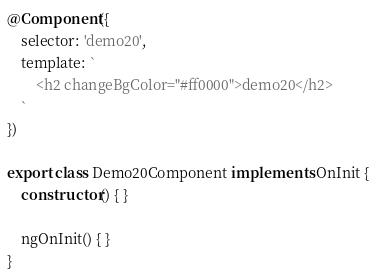Convert code to text. <code><loc_0><loc_0><loc_500><loc_500><_TypeScript_>@Component({
    selector: 'demo20',
    template: `
        <h2 changeBgColor="#ff0000">demo20</h2>
    `
})

export class Demo20Component implements OnInit {
    constructor() { }

    ngOnInit() { }
}</code> 